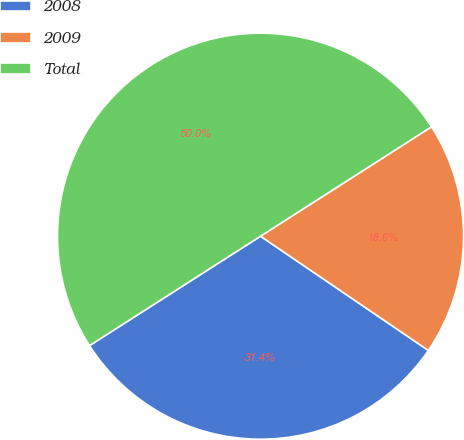Convert chart to OTSL. <chart><loc_0><loc_0><loc_500><loc_500><pie_chart><fcel>2008<fcel>2009<fcel>Total<nl><fcel>31.43%<fcel>18.57%<fcel>50.0%<nl></chart> 